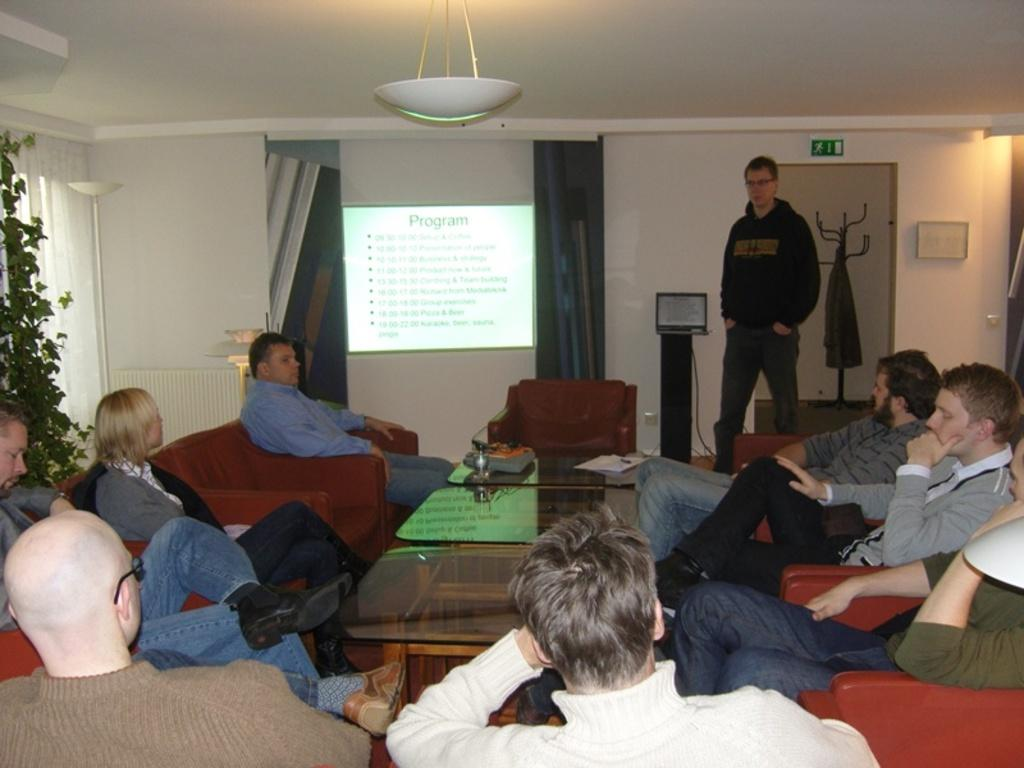What are the people in the image doing? The people in the image are sitting on sofas. Where are the people sitting in relation to each other? The people are sitting around a table. What is the position of the person standing in the image? There is a person standing in front of the seated people. What device can be seen in the image? There is a projector in the image. What type of toothpaste is being used by the person standing in the image? There is no toothpaste present in the image, as it features people sitting on sofas and a standing person around a table with a projector. 